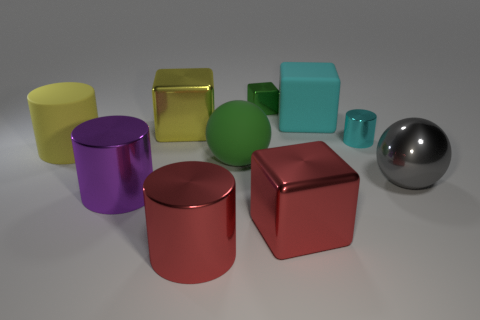What is the material of the small thing that is the same color as the large rubber ball?
Give a very brief answer. Metal. What is the shape of the rubber object that is the same color as the small metal cylinder?
Keep it short and to the point. Cube. There is a matte cube that is the same color as the small cylinder; what is its size?
Your answer should be compact. Large. Is the number of metallic objects left of the big cyan object greater than the number of purple metal cylinders in front of the small cylinder?
Provide a succinct answer. Yes. There is a cylinder that is left of the large purple cylinder; what number of green cubes are in front of it?
Your response must be concise. 0. There is a green thing behind the cyan matte block; is it the same shape as the cyan metallic object?
Your response must be concise. No. There is a red object that is the same shape as the purple thing; what material is it?
Provide a short and direct response. Metal. How many matte things are the same size as the red metal cylinder?
Offer a very short reply. 3. There is a metallic thing that is behind the big green matte ball and right of the large cyan thing; what is its color?
Provide a short and direct response. Cyan. Are there fewer large red cubes than purple rubber blocks?
Provide a succinct answer. No. 